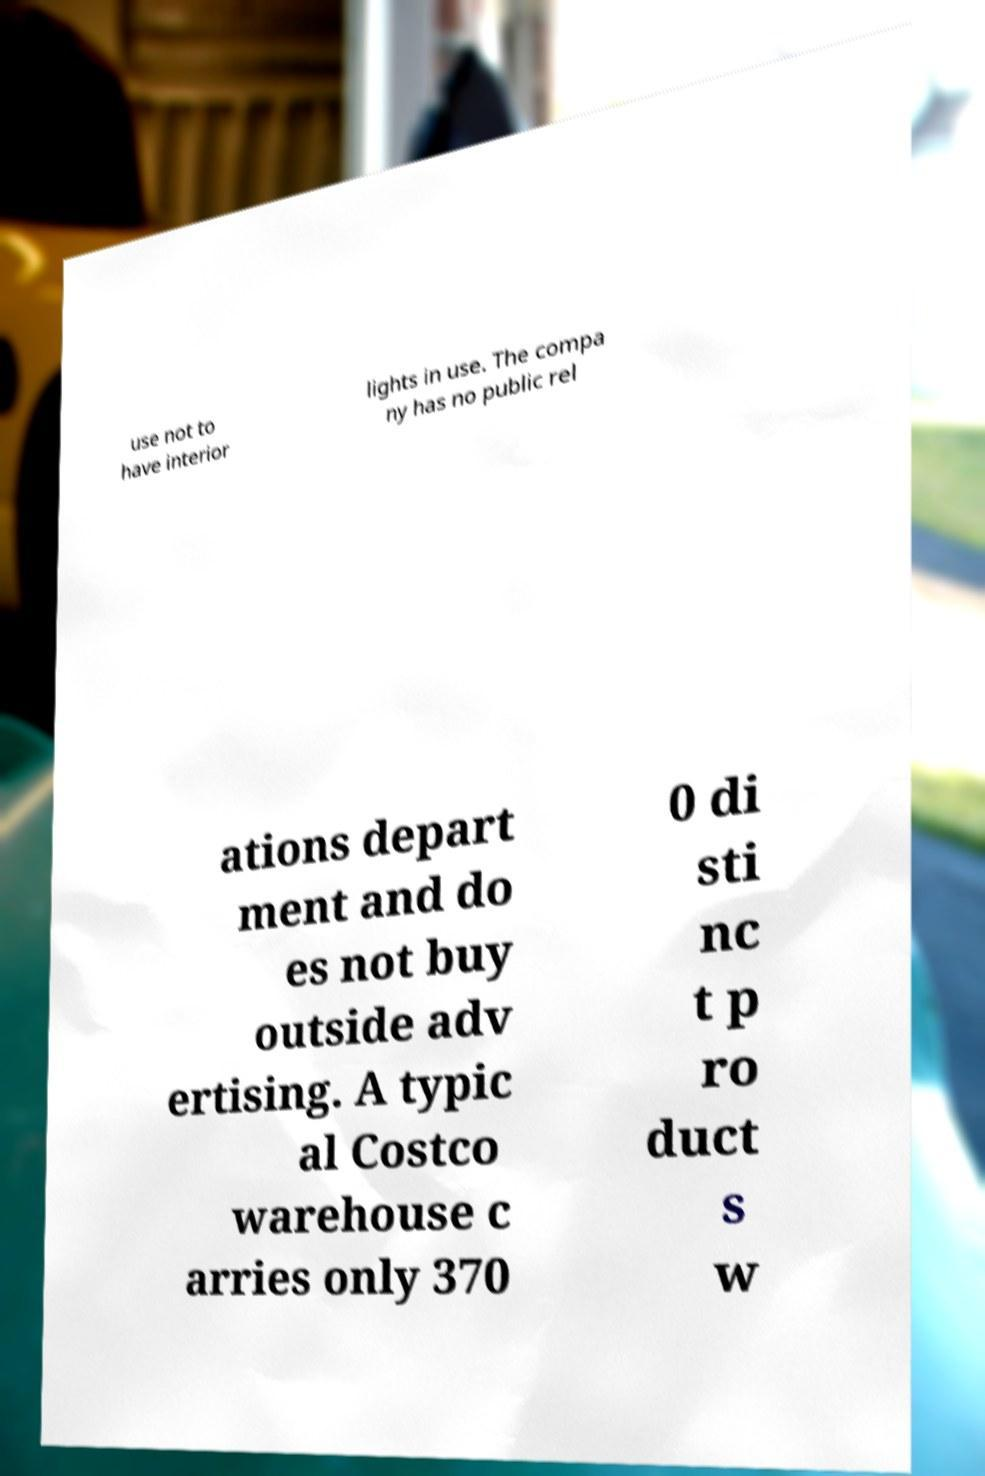Could you assist in decoding the text presented in this image and type it out clearly? use not to have interior lights in use. The compa ny has no public rel ations depart ment and do es not buy outside adv ertising. A typic al Costco warehouse c arries only 370 0 di sti nc t p ro duct s w 